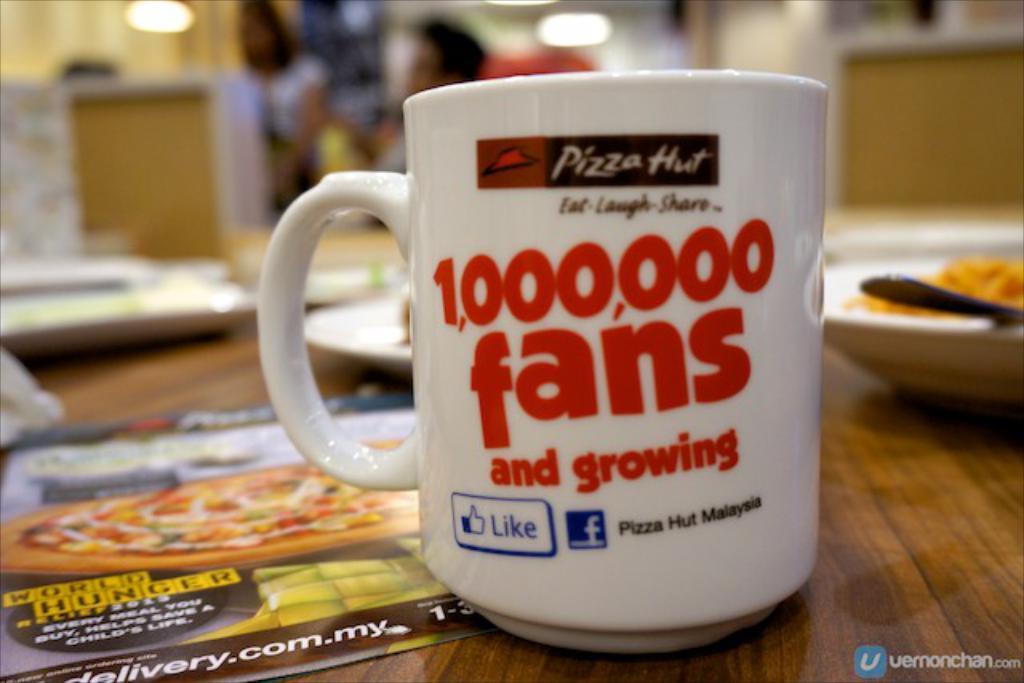Who has a 1,000,000 fans and growing?
Provide a short and direct response. Pizza hut. Where is this pizza hut?
Make the answer very short. Malaysia. 